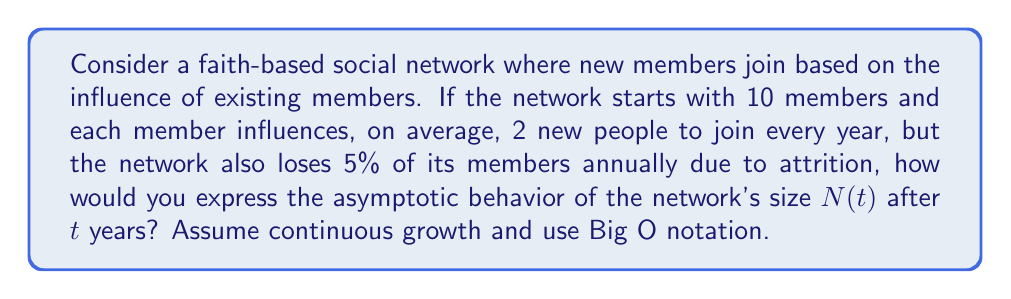Help me with this question. To solve this problem, we need to model the growth of the network over time:

1) Let $N(t)$ be the number of members at time $t$.

2) The growth rate is proportional to the current size:
   $\frac{dN}{dt} = 2N$ (each member influences 2 new people per year)

3) The loss rate is also proportional to the current size:
   $\frac{dN}{dt} = -0.05N$ (5% annual attrition)

4) Combining these, we get the differential equation:
   $\frac{dN}{dt} = 1.95N$

5) The solution to this differential equation is:
   $N(t) = N_0e^{1.95t}$, where $N_0 = 10$ (initial size)

6) Therefore, $N(t) = 10e^{1.95t}$

7) In Big O notation, we ignore constant factors and lower-order terms. $e^{1.95t}$ is of the same order as $e^t$.

8) Thus, the asymptotic behavior of $N(t)$ is $O(e^t)$.

This exponential growth reflects the network effect in faith-based communities, where existing members continually bring in new members, outpacing the attrition rate.
Answer: $O(e^t)$ 